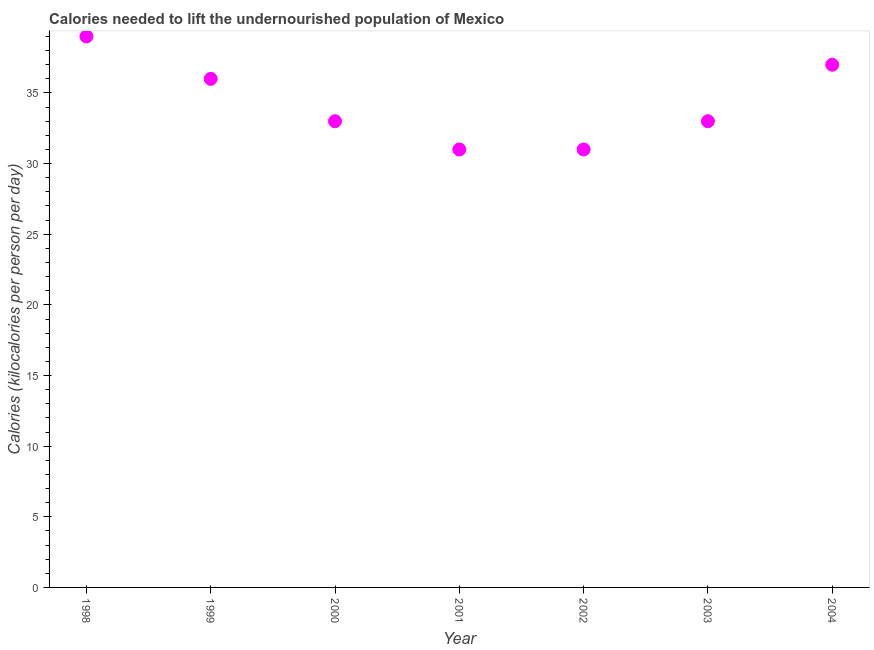What is the depth of food deficit in 2001?
Keep it short and to the point. 31. Across all years, what is the maximum depth of food deficit?
Keep it short and to the point. 39. Across all years, what is the minimum depth of food deficit?
Your answer should be very brief. 31. In which year was the depth of food deficit maximum?
Your answer should be compact. 1998. In which year was the depth of food deficit minimum?
Your response must be concise. 2001. What is the sum of the depth of food deficit?
Make the answer very short. 240. What is the difference between the depth of food deficit in 2002 and 2004?
Your answer should be compact. -6. What is the average depth of food deficit per year?
Provide a short and direct response. 34.29. In how many years, is the depth of food deficit greater than 18 kilocalories?
Offer a terse response. 7. What is the ratio of the depth of food deficit in 1999 to that in 2002?
Your response must be concise. 1.16. Is the depth of food deficit in 2000 less than that in 2004?
Provide a succinct answer. Yes. Is the difference between the depth of food deficit in 1999 and 2002 greater than the difference between any two years?
Offer a terse response. No. What is the difference between the highest and the second highest depth of food deficit?
Your response must be concise. 2. Is the sum of the depth of food deficit in 2001 and 2003 greater than the maximum depth of food deficit across all years?
Your answer should be very brief. Yes. What is the difference between the highest and the lowest depth of food deficit?
Ensure brevity in your answer.  8. Does the depth of food deficit monotonically increase over the years?
Offer a very short reply. No. How many dotlines are there?
Your answer should be very brief. 1. Does the graph contain any zero values?
Make the answer very short. No. Does the graph contain grids?
Your answer should be very brief. No. What is the title of the graph?
Provide a succinct answer. Calories needed to lift the undernourished population of Mexico. What is the label or title of the Y-axis?
Provide a succinct answer. Calories (kilocalories per person per day). What is the Calories (kilocalories per person per day) in 1998?
Provide a short and direct response. 39. What is the Calories (kilocalories per person per day) in 1999?
Your answer should be very brief. 36. What is the Calories (kilocalories per person per day) in 2000?
Keep it short and to the point. 33. What is the Calories (kilocalories per person per day) in 2001?
Give a very brief answer. 31. What is the Calories (kilocalories per person per day) in 2003?
Your answer should be compact. 33. What is the difference between the Calories (kilocalories per person per day) in 1998 and 2001?
Your response must be concise. 8. What is the difference between the Calories (kilocalories per person per day) in 1999 and 2001?
Make the answer very short. 5. What is the difference between the Calories (kilocalories per person per day) in 1999 and 2003?
Ensure brevity in your answer.  3. What is the difference between the Calories (kilocalories per person per day) in 2000 and 2003?
Give a very brief answer. 0. What is the difference between the Calories (kilocalories per person per day) in 2001 and 2003?
Your answer should be compact. -2. What is the difference between the Calories (kilocalories per person per day) in 2002 and 2003?
Keep it short and to the point. -2. What is the difference between the Calories (kilocalories per person per day) in 2003 and 2004?
Give a very brief answer. -4. What is the ratio of the Calories (kilocalories per person per day) in 1998 to that in 1999?
Give a very brief answer. 1.08. What is the ratio of the Calories (kilocalories per person per day) in 1998 to that in 2000?
Your response must be concise. 1.18. What is the ratio of the Calories (kilocalories per person per day) in 1998 to that in 2001?
Provide a succinct answer. 1.26. What is the ratio of the Calories (kilocalories per person per day) in 1998 to that in 2002?
Provide a succinct answer. 1.26. What is the ratio of the Calories (kilocalories per person per day) in 1998 to that in 2003?
Make the answer very short. 1.18. What is the ratio of the Calories (kilocalories per person per day) in 1998 to that in 2004?
Make the answer very short. 1.05. What is the ratio of the Calories (kilocalories per person per day) in 1999 to that in 2000?
Your response must be concise. 1.09. What is the ratio of the Calories (kilocalories per person per day) in 1999 to that in 2001?
Your answer should be very brief. 1.16. What is the ratio of the Calories (kilocalories per person per day) in 1999 to that in 2002?
Offer a very short reply. 1.16. What is the ratio of the Calories (kilocalories per person per day) in 1999 to that in 2003?
Give a very brief answer. 1.09. What is the ratio of the Calories (kilocalories per person per day) in 2000 to that in 2001?
Make the answer very short. 1.06. What is the ratio of the Calories (kilocalories per person per day) in 2000 to that in 2002?
Provide a short and direct response. 1.06. What is the ratio of the Calories (kilocalories per person per day) in 2000 to that in 2003?
Give a very brief answer. 1. What is the ratio of the Calories (kilocalories per person per day) in 2000 to that in 2004?
Ensure brevity in your answer.  0.89. What is the ratio of the Calories (kilocalories per person per day) in 2001 to that in 2003?
Your response must be concise. 0.94. What is the ratio of the Calories (kilocalories per person per day) in 2001 to that in 2004?
Your answer should be compact. 0.84. What is the ratio of the Calories (kilocalories per person per day) in 2002 to that in 2003?
Your answer should be compact. 0.94. What is the ratio of the Calories (kilocalories per person per day) in 2002 to that in 2004?
Offer a terse response. 0.84. What is the ratio of the Calories (kilocalories per person per day) in 2003 to that in 2004?
Provide a succinct answer. 0.89. 